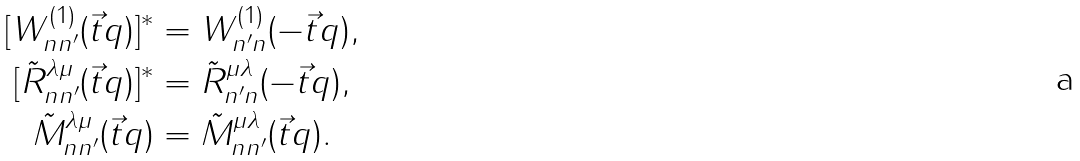Convert formula to latex. <formula><loc_0><loc_0><loc_500><loc_500>[ W ^ { ( 1 ) } _ { n n ^ { \prime } } ( \vec { t } { q } ) ] ^ { * } & = W ^ { ( 1 ) } _ { n ^ { \prime } n } ( - \vec { t } { q } ) , \\ [ \tilde { R } ^ { \lambda \mu } _ { n n ^ { \prime } } ( \vec { t } { q } ) ] ^ { * } & = \tilde { R } ^ { \mu \lambda } _ { n ^ { \prime } n } ( - \vec { t } { q } ) , \\ \tilde { M } ^ { \lambda \mu } _ { n n ^ { \prime } } ( \vec { t } { q } ) & = \tilde { M } ^ { \mu \lambda } _ { n n ^ { \prime } } ( \vec { t } { q } ) .</formula> 